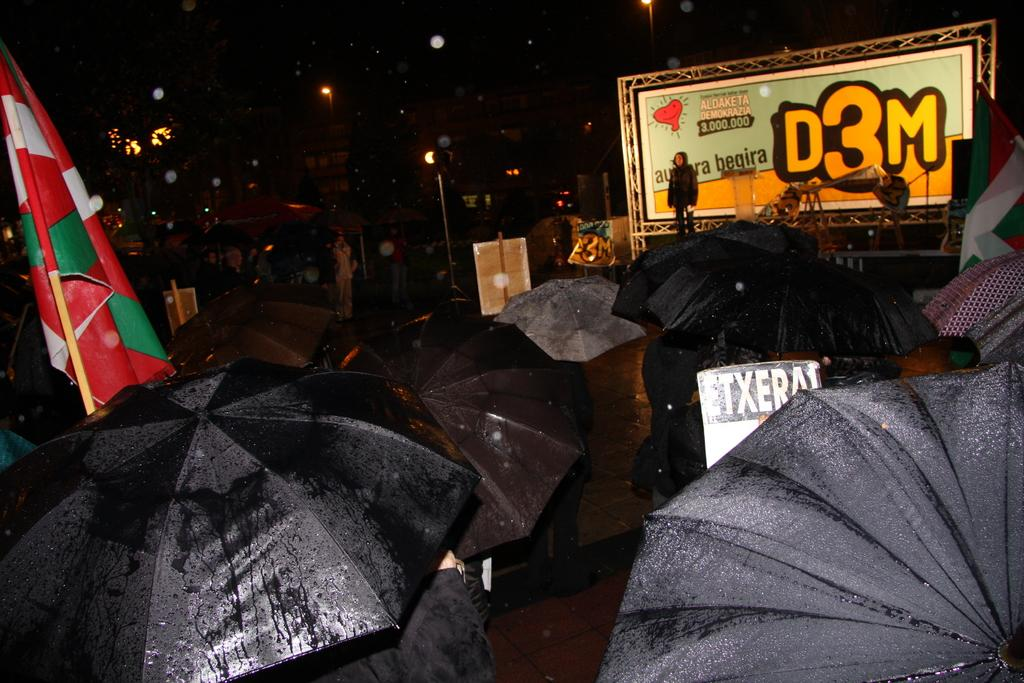What is the lighting condition in the image? The image is taken in a dark environment. What objects can be seen in the image? There are umbrellas, flags, a person, objects, a board, and light poles in the image. What is the background of the image? The sky in the background is dark. What type of yoke is being used by the person in the image? There is no yoke present in the image. What is the ground like in the image? The ground is not visible in the image, as it is taken in a dark environment. 